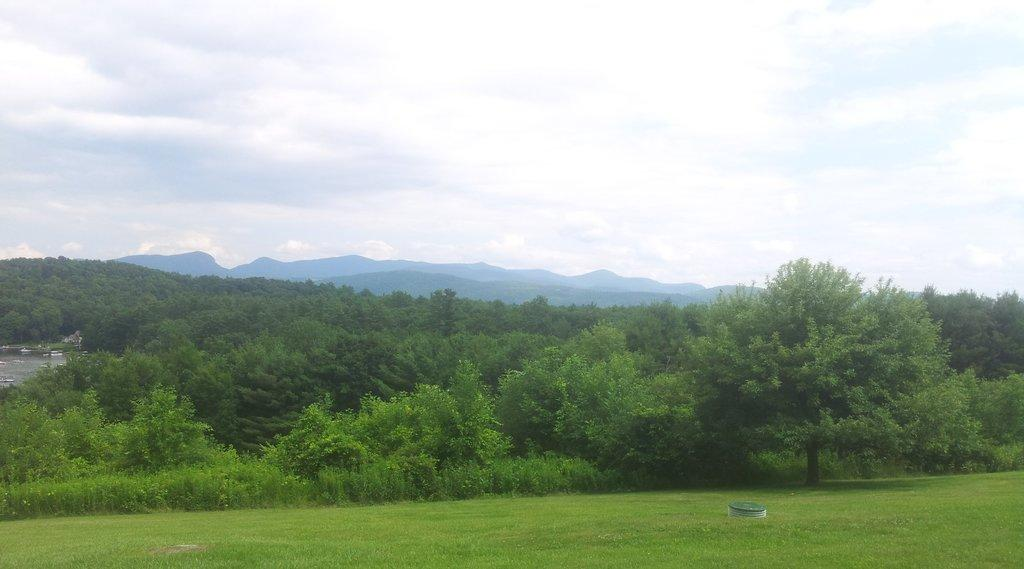What type of natural landform can be seen in the image? There are mountains in the image. What type of vegetation is present in the image? There are trees, plants, and grass in the image. What part of the natural environment is visible in the image? The sky is visible in the image. What type of battle is taking place in the image? There is no battle present in the image; it features mountains, trees, plants, grass, and the sky. What kind of haircut is visible on the trees in the image? There are no haircuts present in the image, as trees do not have hair. 